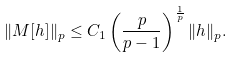Convert formula to latex. <formula><loc_0><loc_0><loc_500><loc_500>\| M [ h ] \| _ { p } \leq C _ { 1 } \left ( \frac { p } { p - 1 } \right ) ^ { \frac { 1 } { p } } \| h \| _ { p } .</formula> 